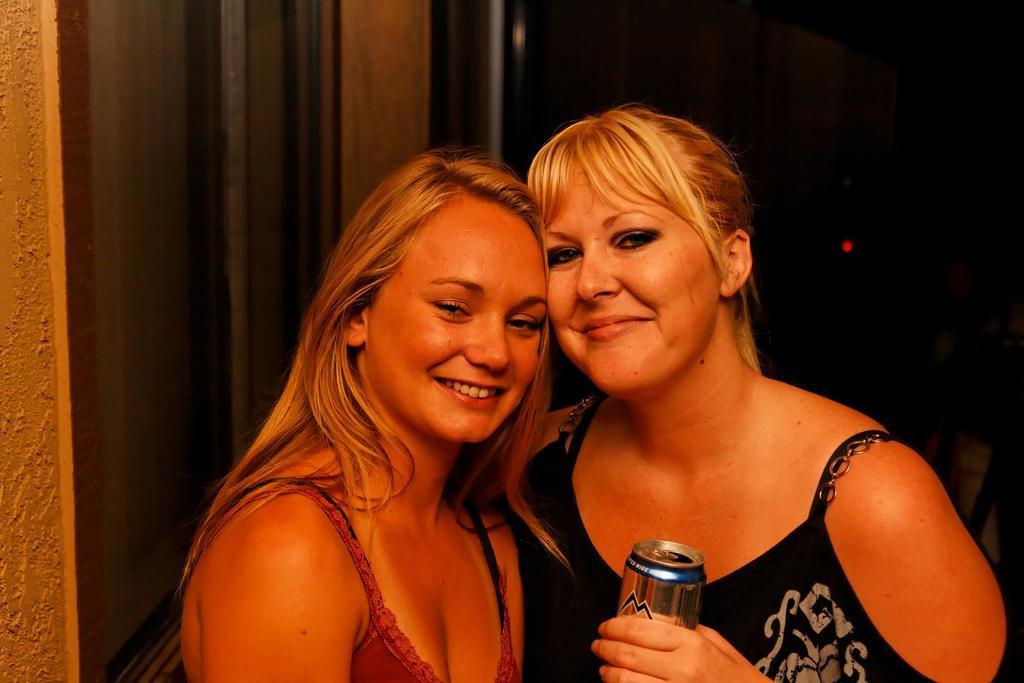Please provide a concise description of this image. This image consists of two women. On the right, the woman is wearing a black dress and holding a tin. In the background, it looks like a door. And the background is too dark. 